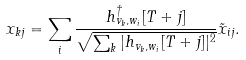<formula> <loc_0><loc_0><loc_500><loc_500>x _ { k j } = \sum _ { i } \frac { h _ { v _ { k } , w _ { i } } ^ { \dagger } [ T + j ] } { \sqrt { \sum _ { k } | h _ { v _ { k } , w _ { i } } [ T + j ] | ^ { 2 } } } \tilde { x } _ { i j } .</formula> 